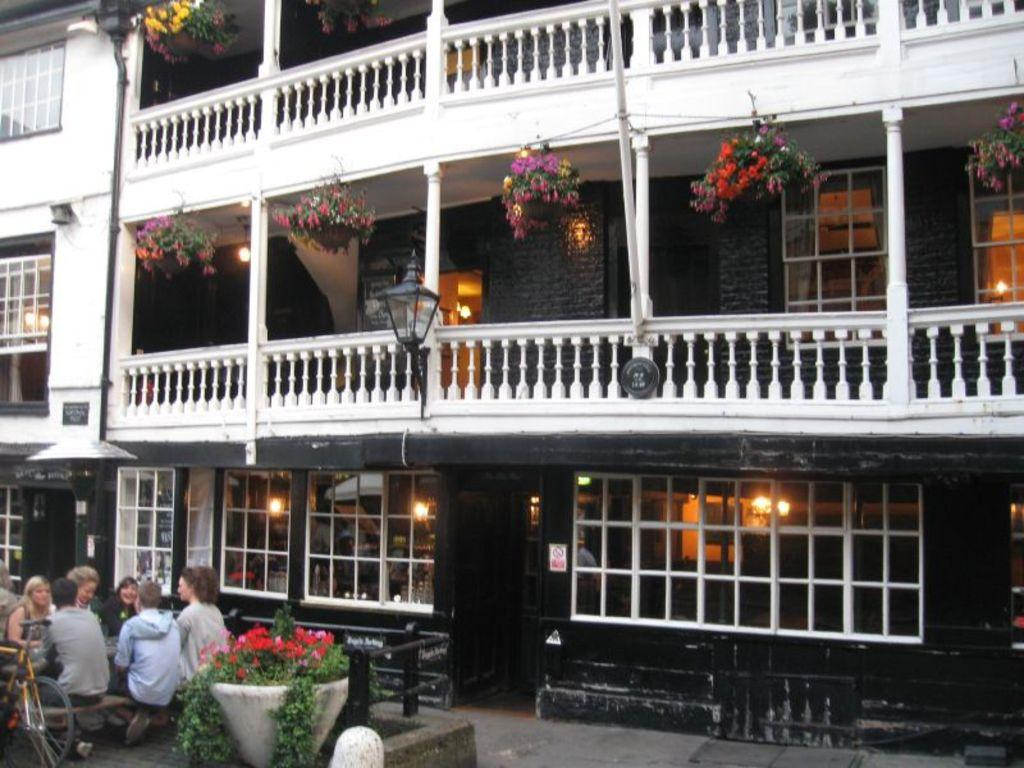What is the main structure in the image? There is a building in the image. What is attached to the building? There are plants hanging on the building. Who or what can be seen in the image besides the building and plants? There are people visible in the image. What mode of transportation can be seen in the image? There is a bicycle in the image. Can you tell me how many goats are grazing near the building in the image? There are no goats present in the image; it only features a building, plants, people, and a bicycle. What type of knife is being used to cut the plants on the building? There is no knife visible in the image, and the plants are hanging, not being cut. 